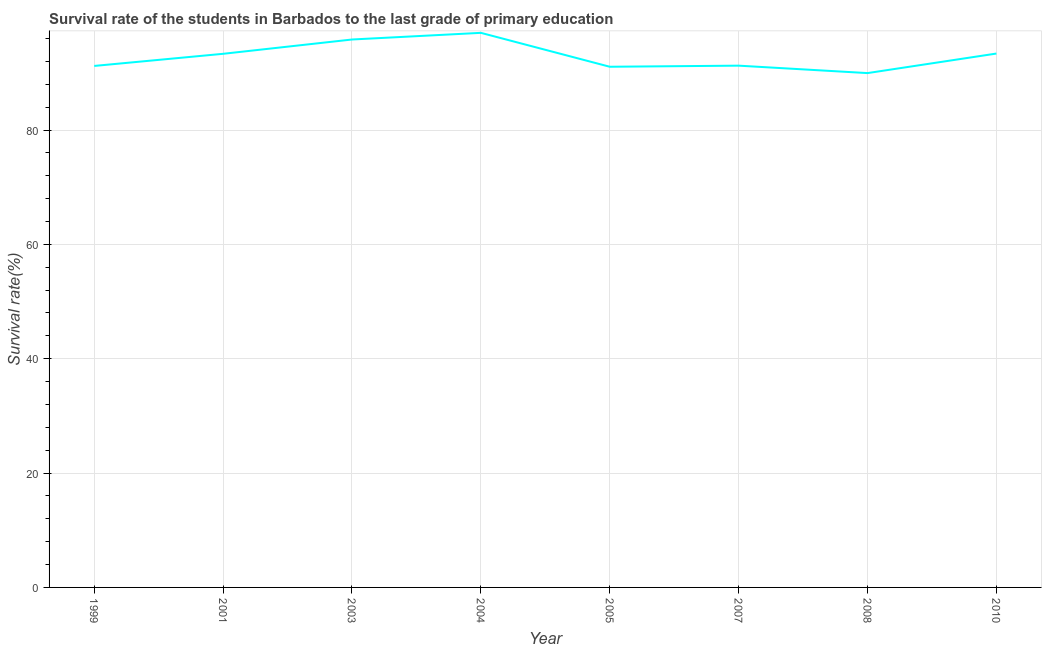What is the survival rate in primary education in 2008?
Offer a very short reply. 89.96. Across all years, what is the maximum survival rate in primary education?
Make the answer very short. 97. Across all years, what is the minimum survival rate in primary education?
Offer a terse response. 89.96. In which year was the survival rate in primary education minimum?
Make the answer very short. 2008. What is the sum of the survival rate in primary education?
Your answer should be compact. 743.03. What is the difference between the survival rate in primary education in 2001 and 2010?
Keep it short and to the point. -0.04. What is the average survival rate in primary education per year?
Provide a short and direct response. 92.88. What is the median survival rate in primary education?
Your answer should be very brief. 92.3. In how many years, is the survival rate in primary education greater than 72 %?
Offer a terse response. 8. Do a majority of the years between 2003 and 2005 (inclusive) have survival rate in primary education greater than 32 %?
Your answer should be very brief. Yes. What is the ratio of the survival rate in primary education in 2001 to that in 2008?
Your response must be concise. 1.04. Is the difference between the survival rate in primary education in 2004 and 2007 greater than the difference between any two years?
Offer a very short reply. No. What is the difference between the highest and the second highest survival rate in primary education?
Your answer should be very brief. 1.17. What is the difference between the highest and the lowest survival rate in primary education?
Keep it short and to the point. 7.04. Does the survival rate in primary education monotonically increase over the years?
Your response must be concise. No. How many years are there in the graph?
Offer a very short reply. 8. What is the difference between two consecutive major ticks on the Y-axis?
Ensure brevity in your answer.  20. What is the title of the graph?
Your response must be concise. Survival rate of the students in Barbados to the last grade of primary education. What is the label or title of the Y-axis?
Ensure brevity in your answer.  Survival rate(%). What is the Survival rate(%) of 1999?
Offer a terse response. 91.21. What is the Survival rate(%) in 2001?
Offer a terse response. 93.33. What is the Survival rate(%) in 2003?
Offer a very short reply. 95.83. What is the Survival rate(%) in 2004?
Your response must be concise. 97. What is the Survival rate(%) in 2005?
Offer a terse response. 91.07. What is the Survival rate(%) of 2007?
Your answer should be very brief. 91.26. What is the Survival rate(%) in 2008?
Provide a short and direct response. 89.96. What is the Survival rate(%) of 2010?
Provide a short and direct response. 93.37. What is the difference between the Survival rate(%) in 1999 and 2001?
Provide a succinct answer. -2.12. What is the difference between the Survival rate(%) in 1999 and 2003?
Ensure brevity in your answer.  -4.62. What is the difference between the Survival rate(%) in 1999 and 2004?
Your answer should be compact. -5.79. What is the difference between the Survival rate(%) in 1999 and 2005?
Offer a very short reply. 0.14. What is the difference between the Survival rate(%) in 1999 and 2007?
Your answer should be very brief. -0.05. What is the difference between the Survival rate(%) in 1999 and 2008?
Offer a very short reply. 1.25. What is the difference between the Survival rate(%) in 1999 and 2010?
Offer a very short reply. -2.17. What is the difference between the Survival rate(%) in 2001 and 2003?
Your answer should be compact. -2.5. What is the difference between the Survival rate(%) in 2001 and 2004?
Offer a very short reply. -3.67. What is the difference between the Survival rate(%) in 2001 and 2005?
Your response must be concise. 2.27. What is the difference between the Survival rate(%) in 2001 and 2007?
Offer a terse response. 2.07. What is the difference between the Survival rate(%) in 2001 and 2008?
Provide a succinct answer. 3.37. What is the difference between the Survival rate(%) in 2001 and 2010?
Your answer should be very brief. -0.04. What is the difference between the Survival rate(%) in 2003 and 2004?
Provide a succinct answer. -1.17. What is the difference between the Survival rate(%) in 2003 and 2005?
Your answer should be very brief. 4.77. What is the difference between the Survival rate(%) in 2003 and 2007?
Your answer should be very brief. 4.57. What is the difference between the Survival rate(%) in 2003 and 2008?
Your answer should be compact. 5.87. What is the difference between the Survival rate(%) in 2003 and 2010?
Your answer should be very brief. 2.46. What is the difference between the Survival rate(%) in 2004 and 2005?
Your response must be concise. 5.93. What is the difference between the Survival rate(%) in 2004 and 2007?
Ensure brevity in your answer.  5.74. What is the difference between the Survival rate(%) in 2004 and 2008?
Give a very brief answer. 7.04. What is the difference between the Survival rate(%) in 2004 and 2010?
Make the answer very short. 3.62. What is the difference between the Survival rate(%) in 2005 and 2007?
Your answer should be compact. -0.19. What is the difference between the Survival rate(%) in 2005 and 2008?
Make the answer very short. 1.11. What is the difference between the Survival rate(%) in 2005 and 2010?
Offer a very short reply. -2.31. What is the difference between the Survival rate(%) in 2007 and 2008?
Your answer should be very brief. 1.3. What is the difference between the Survival rate(%) in 2007 and 2010?
Keep it short and to the point. -2.12. What is the difference between the Survival rate(%) in 2008 and 2010?
Provide a short and direct response. -3.42. What is the ratio of the Survival rate(%) in 1999 to that in 2003?
Your answer should be compact. 0.95. What is the ratio of the Survival rate(%) in 1999 to that in 2008?
Offer a very short reply. 1.01. What is the ratio of the Survival rate(%) in 2001 to that in 2003?
Provide a succinct answer. 0.97. What is the ratio of the Survival rate(%) in 2001 to that in 2004?
Your answer should be compact. 0.96. What is the ratio of the Survival rate(%) in 2001 to that in 2005?
Offer a very short reply. 1.02. What is the ratio of the Survival rate(%) in 2001 to that in 2007?
Your answer should be compact. 1.02. What is the ratio of the Survival rate(%) in 2001 to that in 2008?
Your answer should be very brief. 1.04. What is the ratio of the Survival rate(%) in 2001 to that in 2010?
Your answer should be compact. 1. What is the ratio of the Survival rate(%) in 2003 to that in 2004?
Make the answer very short. 0.99. What is the ratio of the Survival rate(%) in 2003 to that in 2005?
Make the answer very short. 1.05. What is the ratio of the Survival rate(%) in 2003 to that in 2008?
Keep it short and to the point. 1.06. What is the ratio of the Survival rate(%) in 2004 to that in 2005?
Provide a succinct answer. 1.06. What is the ratio of the Survival rate(%) in 2004 to that in 2007?
Give a very brief answer. 1.06. What is the ratio of the Survival rate(%) in 2004 to that in 2008?
Your answer should be very brief. 1.08. What is the ratio of the Survival rate(%) in 2004 to that in 2010?
Ensure brevity in your answer.  1.04. What is the ratio of the Survival rate(%) in 2005 to that in 2007?
Your response must be concise. 1. What is the ratio of the Survival rate(%) in 2005 to that in 2008?
Offer a very short reply. 1.01. What is the ratio of the Survival rate(%) in 2007 to that in 2010?
Your answer should be compact. 0.98. 